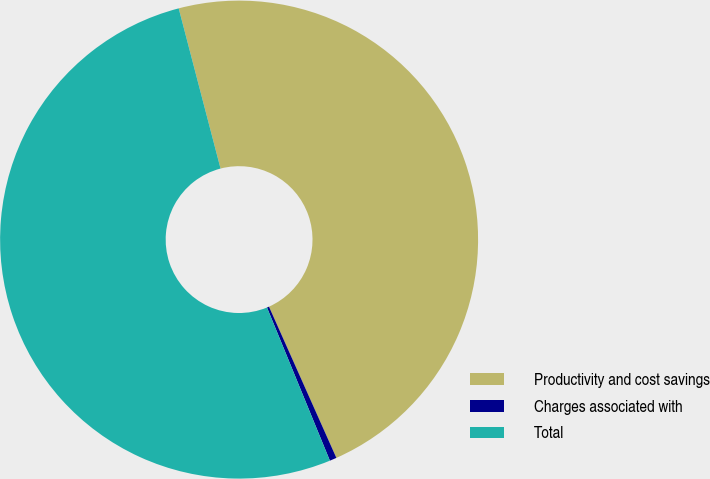<chart> <loc_0><loc_0><loc_500><loc_500><pie_chart><fcel>Productivity and cost savings<fcel>Charges associated with<fcel>Total<nl><fcel>47.39%<fcel>0.47%<fcel>52.13%<nl></chart> 